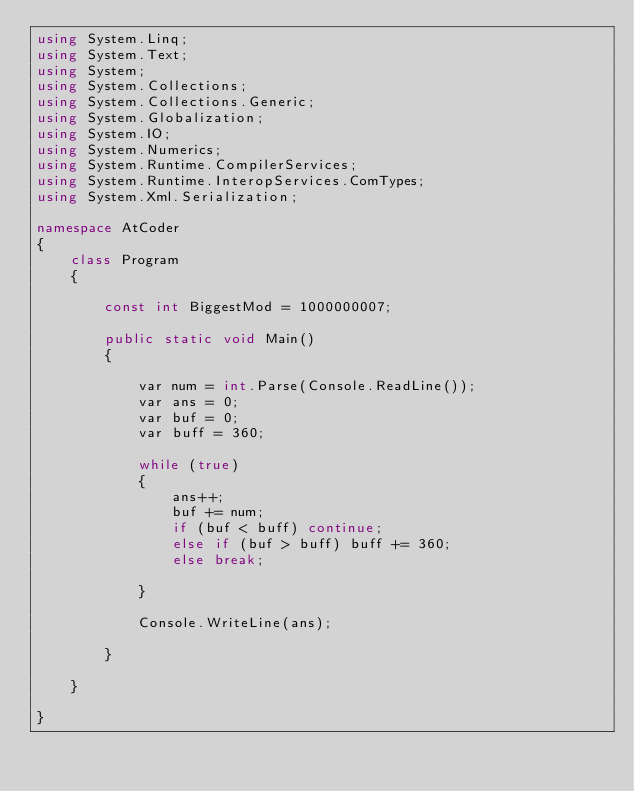Convert code to text. <code><loc_0><loc_0><loc_500><loc_500><_C#_>using System.Linq;
using System.Text;
using System;
using System.Collections;
using System.Collections.Generic;
using System.Globalization;
using System.IO;
using System.Numerics;
using System.Runtime.CompilerServices;
using System.Runtime.InteropServices.ComTypes;
using System.Xml.Serialization;

namespace AtCoder
{
    class Program
    {

        const int BiggestMod = 1000000007;

        public static void Main()
        {

            var num = int.Parse(Console.ReadLine());
            var ans = 0;
            var buf = 0;
            var buff = 360;

            while (true)
            {
                ans++;
                buf += num;
                if (buf < buff) continue;
                else if (buf > buff) buff += 360;
                else break;

            }

            Console.WriteLine(ans);

        }

    }

}</code> 